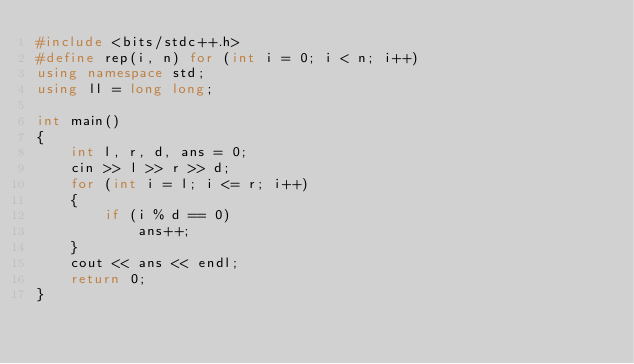Convert code to text. <code><loc_0><loc_0><loc_500><loc_500><_C++_>#include <bits/stdc++.h>
#define rep(i, n) for (int i = 0; i < n; i++)
using namespace std;
using ll = long long;

int main()
{
    int l, r, d, ans = 0;
    cin >> l >> r >> d;
    for (int i = l; i <= r; i++)
    {
        if (i % d == 0)
            ans++;
    }
    cout << ans << endl;
    return 0;
}</code> 